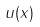Convert formula to latex. <formula><loc_0><loc_0><loc_500><loc_500>u ( x )</formula> 